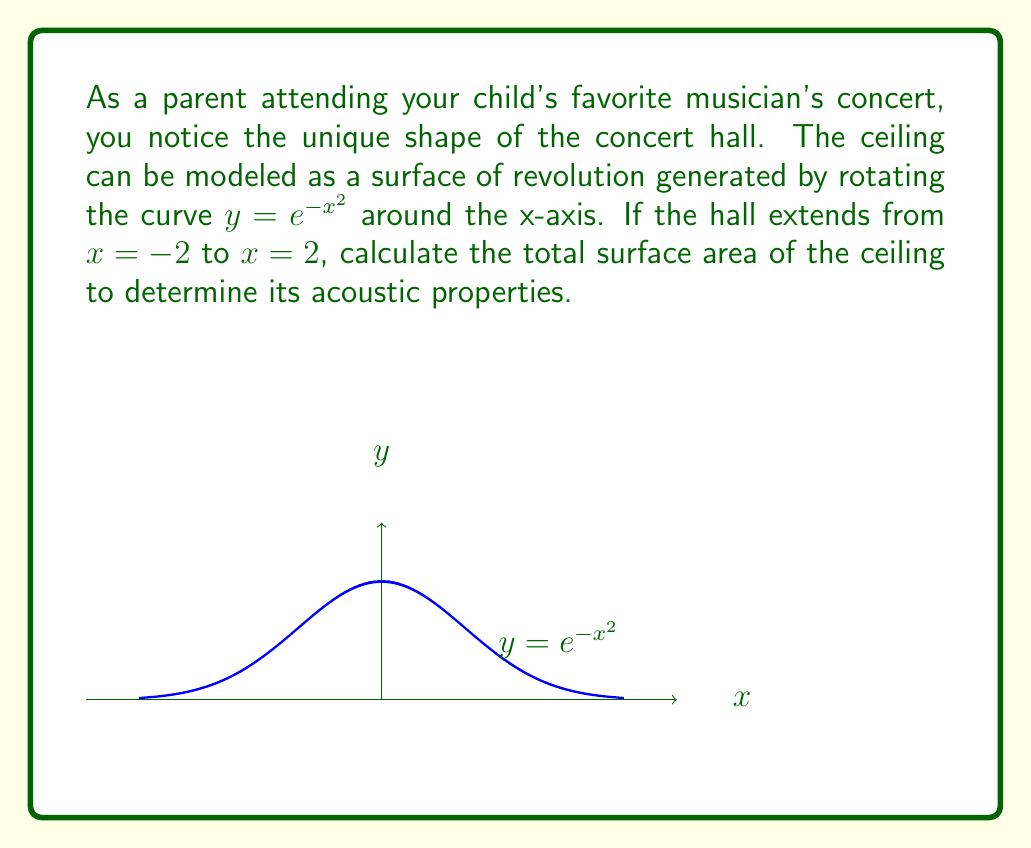Show me your answer to this math problem. Let's approach this step-by-step using differential geometry:

1) For a surface of revolution, the surface area is given by the formula:

   $$A = 2\pi \int_{a}^{b} f(x)\sqrt{1 + [f'(x)]^2} dx$$

   where $f(x)$ is the function being rotated and $[a,b]$ is the interval.

2) In our case, $f(x) = e^{-x^2}$, $a = -2$, and $b = 2$.

3) We need to find $f'(x)$:
   $$f'(x) = -2xe^{-x^2}$$

4) Now, let's substitute these into our surface area formula:

   $$A = 2\pi \int_{-2}^{2} e^{-x^2}\sqrt{1 + (-2xe^{-x^2})^2} dx$$

5) Simplify the integrand:

   $$A = 2\pi \int_{-2}^{2} e^{-x^2}\sqrt{1 + 4x^2e^{-2x^2}} dx$$

6) This integral cannot be evaluated analytically. We need to use numerical integration methods.

7) Using a computational tool (like Simpson's rule or adaptive quadrature), we can approximate this integral:

   $$A \approx 14.7516$$

8) The units would be square units (e.g., square meters), depending on the scale of the concert hall.

This surface area affects how sound waves reflect and propagate in the hall, influencing acoustics.
Answer: $14.7516$ square units 